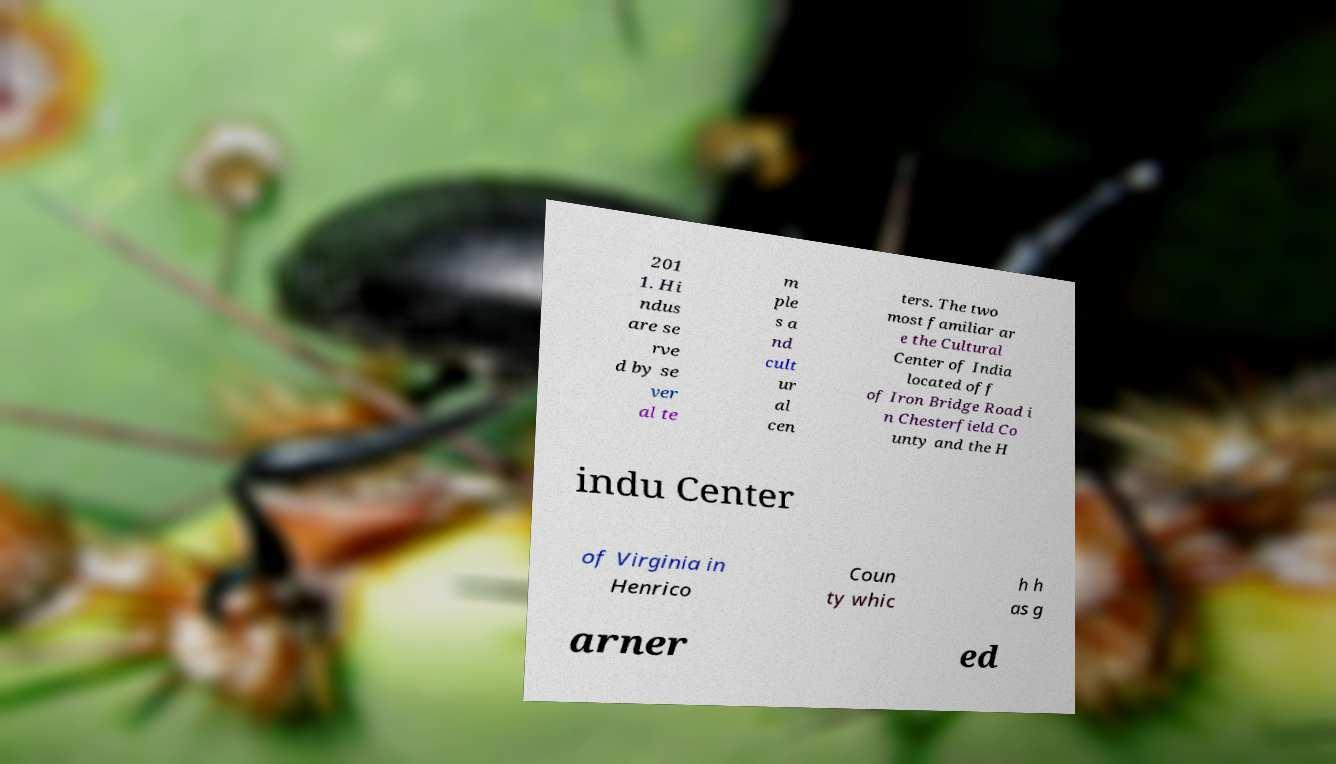Could you assist in decoding the text presented in this image and type it out clearly? 201 1. Hi ndus are se rve d by se ver al te m ple s a nd cult ur al cen ters. The two most familiar ar e the Cultural Center of India located off of Iron Bridge Road i n Chesterfield Co unty and the H indu Center of Virginia in Henrico Coun ty whic h h as g arner ed 